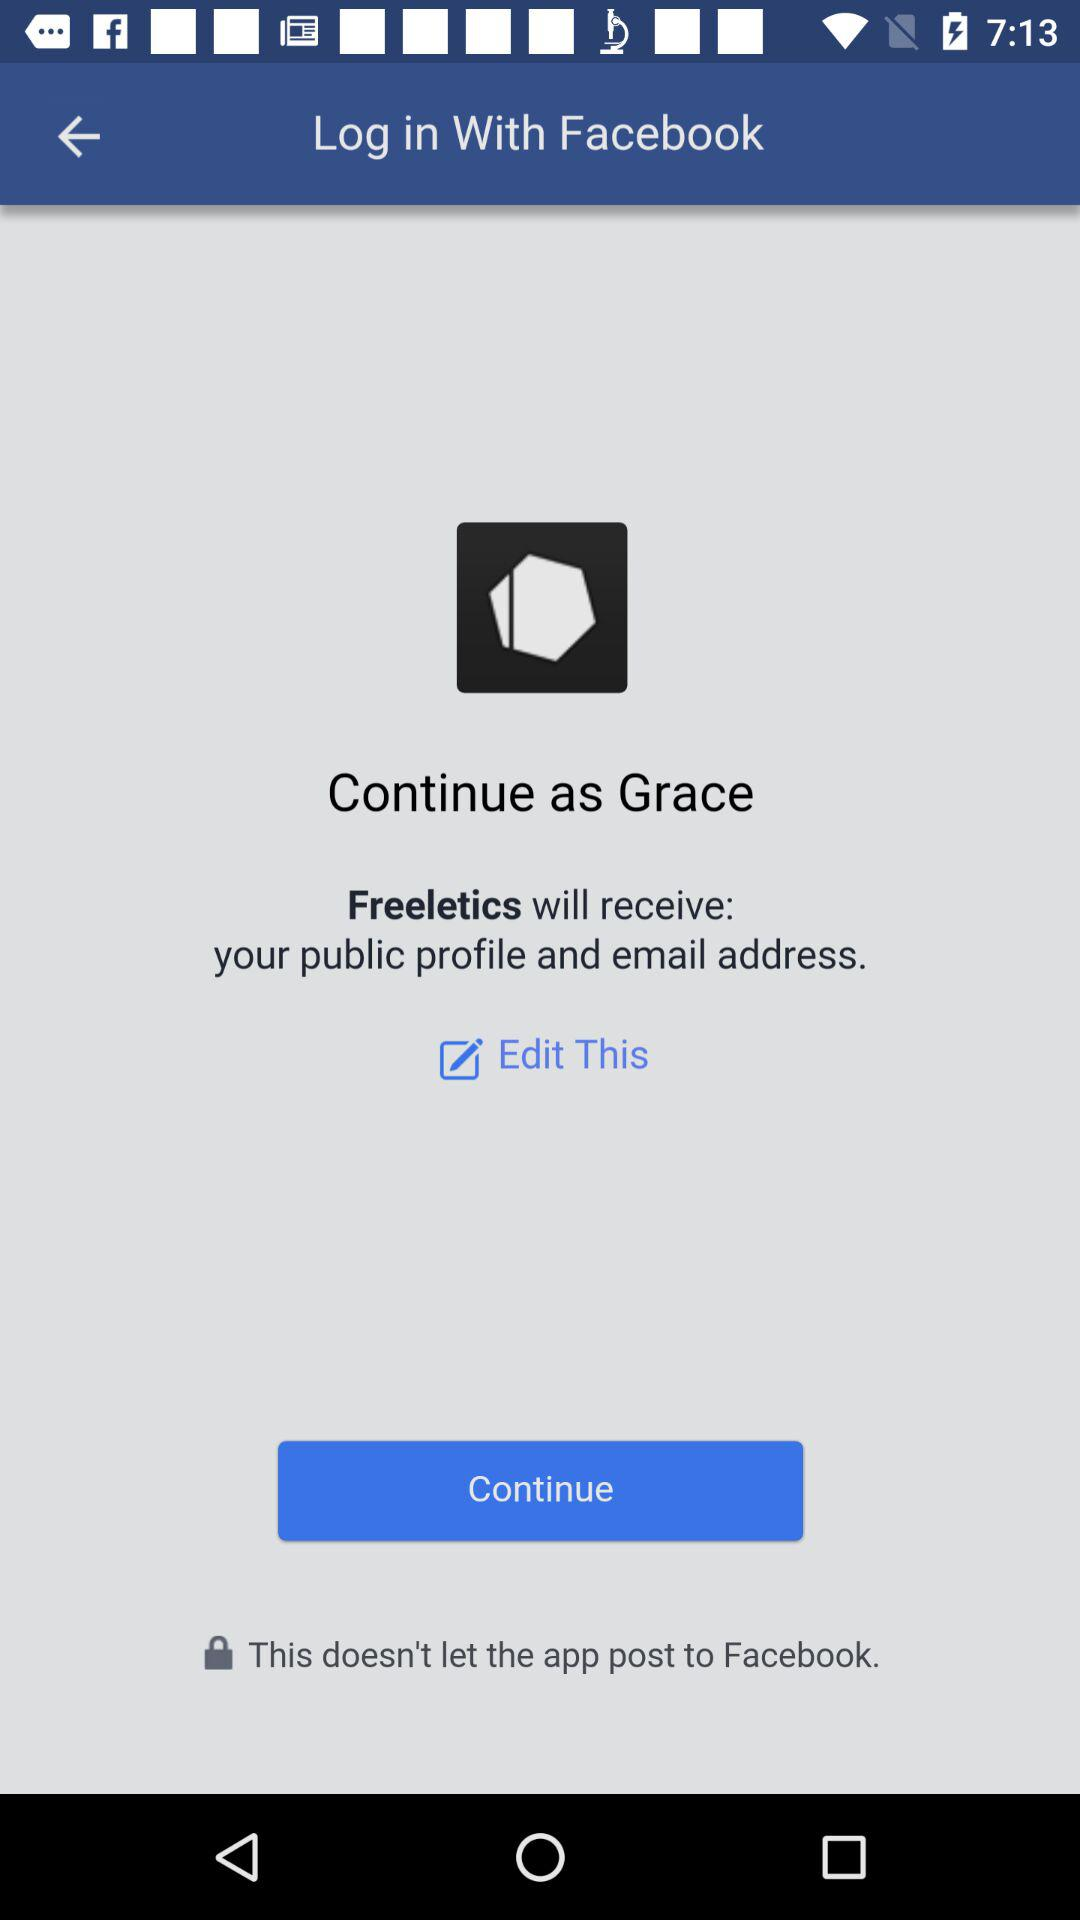What is the user name to continue the profile? The user name to continue the profile is Grace. 